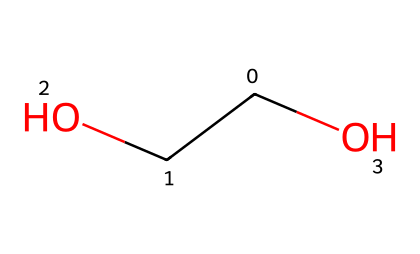What is the main functional group present in this chemical? The chemical structure shows a hydroxyl group (-OH), which is characteristic of alcohols and polyalcohols. This functional group is identified by the oxygen atom bonded to a hydrogen atom.
Answer: hydroxyl group How many carbon atoms are in the structure? The SMILES representation contains two carbon atoms, which can be counted from the representation. The 'C' indicates the presence of carbon, and there are two instances of 'C' in the structure.
Answer: two What type of polymer is represented by this structure? The structure given corresponds to polyethylene glycol, a type of polyether, which is identified by its repeating units of ethylene glycol and the presence of ether linkages.
Answer: polyether How many oxygen atoms are present in the compound? There are two oxygen atoms in the structure; one in the hydroxyl group and one as part of the ether link. Each is represented with an 'O' in the SMILES notation.
Answer: two What is the molecular formula for this structure? To determine the molecular formula, we total the numbers of each type of atom present: 2 carbon (C), 6 hydrogen (H), and 2 oxygen (O), leading us to the overall formula of C2H6O2.
Answer: C2H6O2 